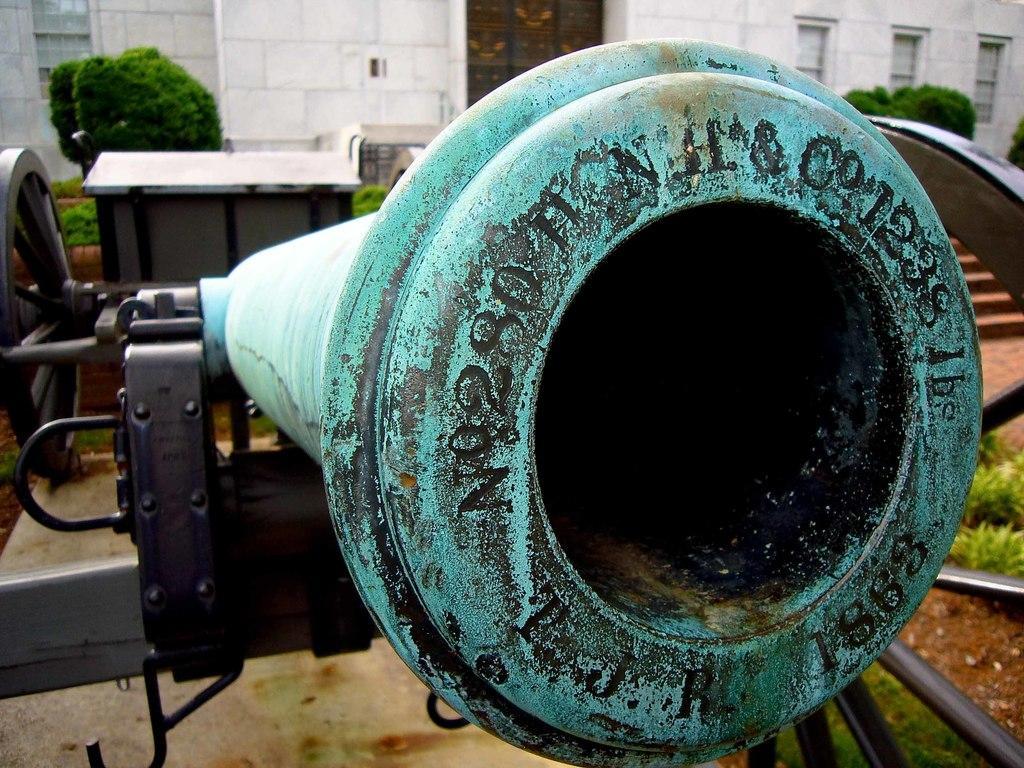Can you describe this image briefly? In this picture there is a close view of the green color canon in the front. Behind there is a white color building wall and some green plants. 